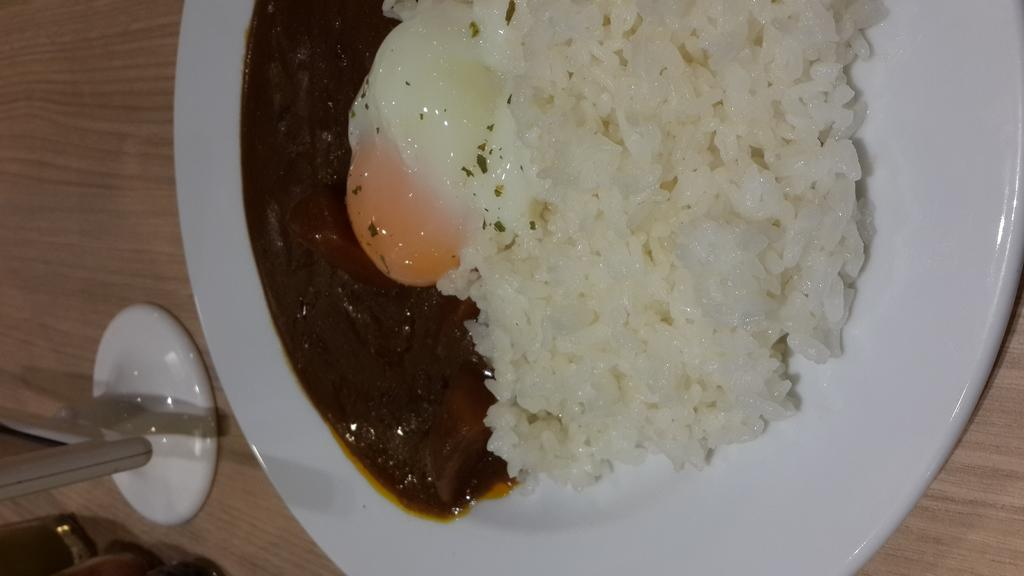What is on the table in the image? There is a plate on the table, and there are objects on the table. What is on the plate? The plate contains rice, and there is food on the plate. What type of lock is securing the baby's wrist in the image? There is no baby or lock present in the image; it only features a plate with rice and other food on a table. 